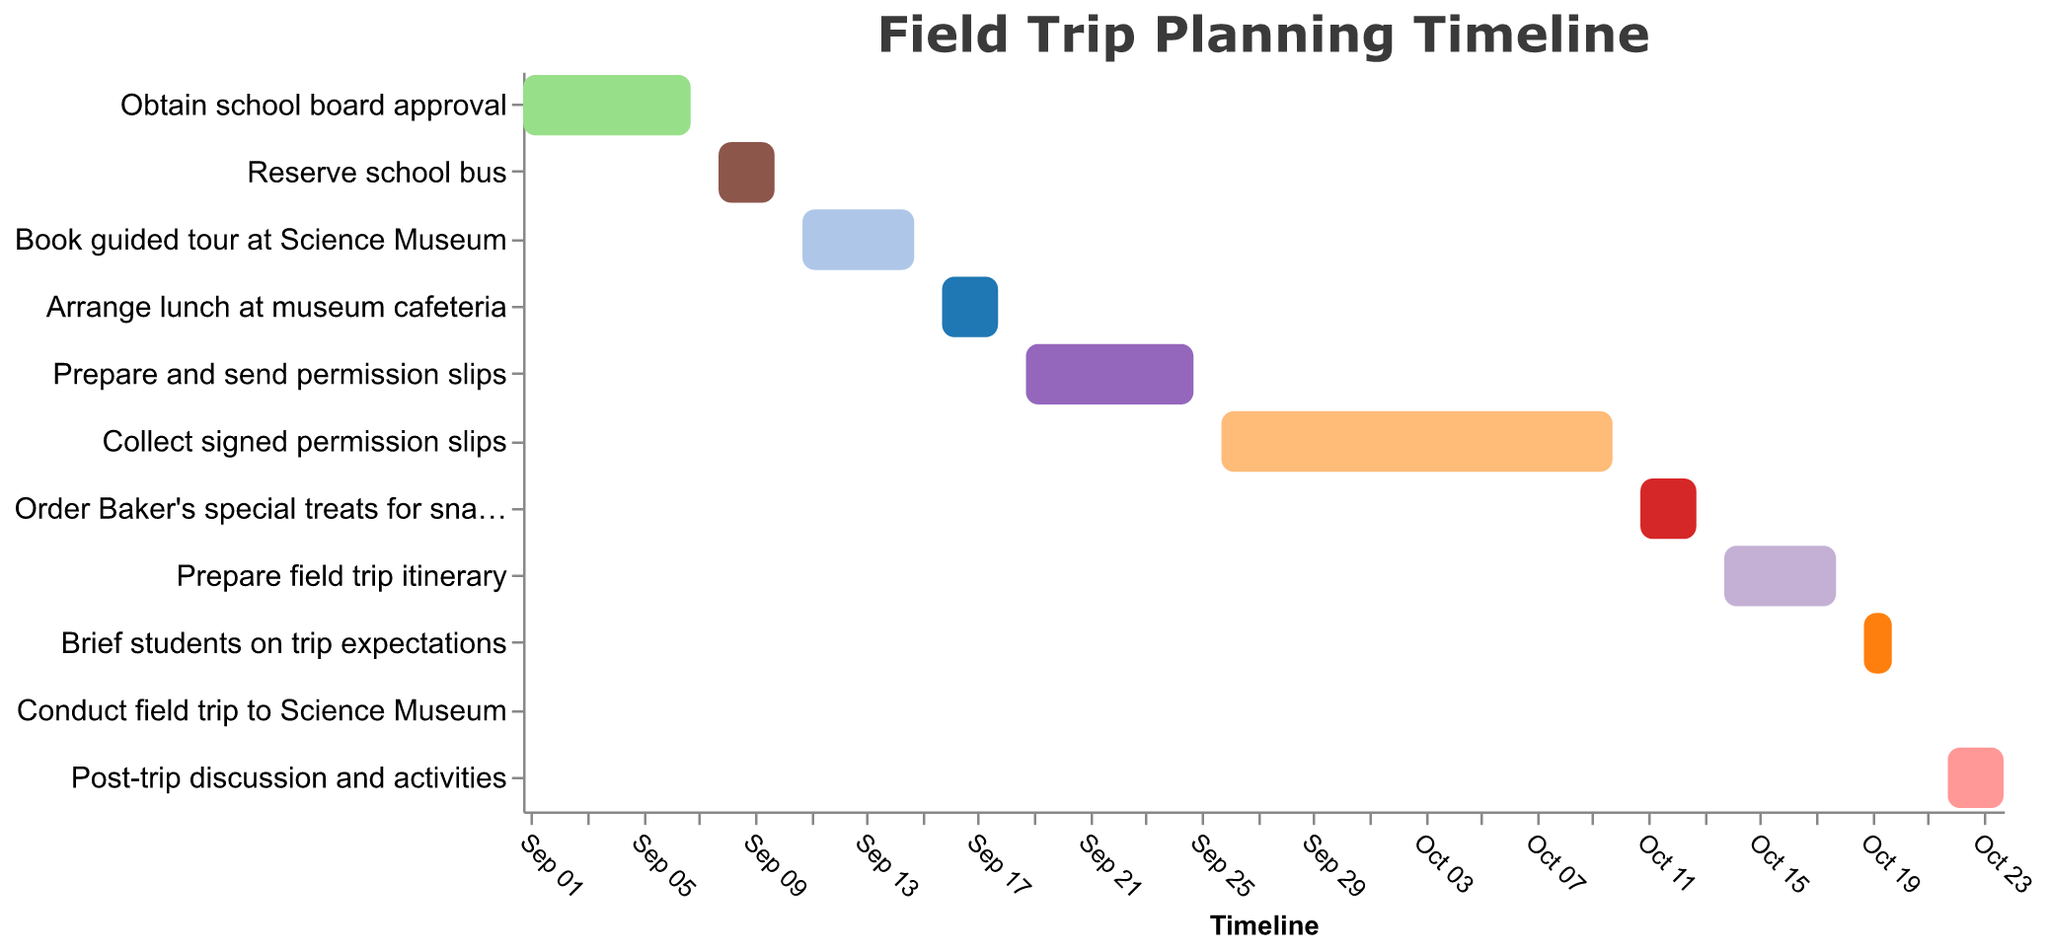When does the task 'Reserve school bus' start and end? The 'Reserve school bus' task starts on 2023-09-08 and ends on 2023-09-10, as indicated by the bar corresponding to this task in the Gantt chart.
Answer: 2023-09-08 to 2023-09-10 What are the first and last tasks in the timeline? The first task is 'Obtain school board approval,' which starts on 2023-09-01, and the last task is 'Post-trip discussion and activities,' ending on 2023-10-24, as evidenced by their positions on the Gantt chart.
Answer: Obtain school board approval, Post-trip discussion and activities How many days is the task 'Collect signed permission slips' scheduled to take? The 'Collect signed permission slips' task starts on 2023-09-26 and ends on 2023-10-10. Counting the days between these dates gives 15 days.
Answer: 15 days Which task has the shortest duration? The 'Conduct field trip to Science Museum' task has the shortest duration, as it is scheduled for only one day, on 2023-10-21, indicated by the bar in the Gantt chart.
Answer: Conduct field trip to Science Museum Between which dates is the 'Prepare field trip itinerary' task scheduled? The 'Prepare field trip itinerary' task is scheduled from 2023-10-14 to 2023-10-18, as shown by the bar spanning these dates in the Gantt chart.
Answer: 2023-10-14 to 2023-10-18 Which task occurs immediately after 'Book guided tour at Science Museum'? The task that occurs immediately after 'Book guided tour at Science Museum' is 'Arrange lunch at museum cafeteria,' which starts on 2023-09-16, right after the previous task ends on 2023-09-15.
Answer: Arrange lunch at museum cafeteria What is the total duration of the planning period from the start of the first task to the end of the last task? The first task starts on 2023-09-01, and the last task ends on 2023-10-24. The total duration is from 2023-09-01 to 2023-10-24, which is 54 days.
Answer: 54 days Which tasks are scheduled to occur simultaneously at any point in time? Simultaneous tasks include 'Collect signed permission slips' (2023-09-26 to 2023-10-10) and 'Prepare and send permission slips' (2023-09-19 to 2023-09-25), 'Order Baker's special treats for snacks' (2023-10-11 to 2023-10-13) and 'Prepare field trip itinerary' (2023-10-14 to 2023-10-18).
Answer: Collect signed permission slips and Prepare and send permission slips; Order Baker's special treats for snacks and Prepare field trip itinerary 